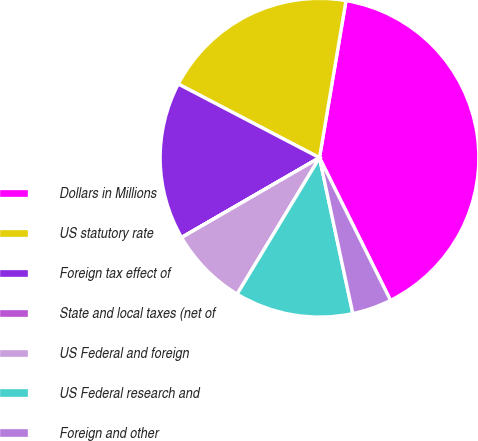Convert chart to OTSL. <chart><loc_0><loc_0><loc_500><loc_500><pie_chart><fcel>Dollars in Millions<fcel>US statutory rate<fcel>Foreign tax effect of<fcel>State and local taxes (net of<fcel>US Federal and foreign<fcel>US Federal research and<fcel>Foreign and other<nl><fcel>39.99%<fcel>20.0%<fcel>16.0%<fcel>0.01%<fcel>8.0%<fcel>12.0%<fcel>4.0%<nl></chart> 